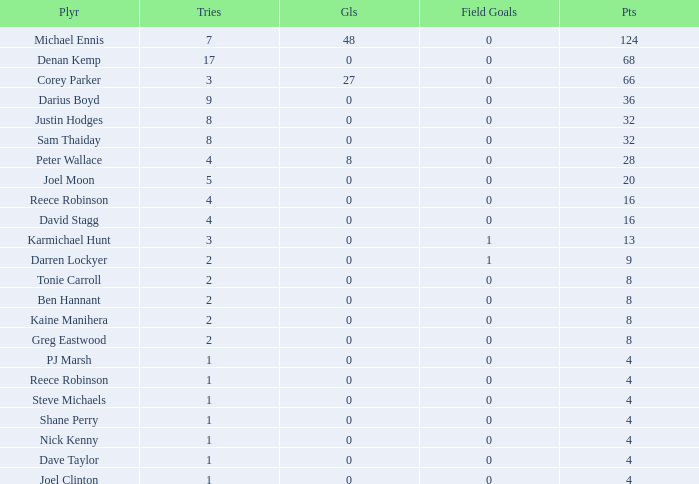Given that dave taylor has more than one try, what is his total goal count? None. 